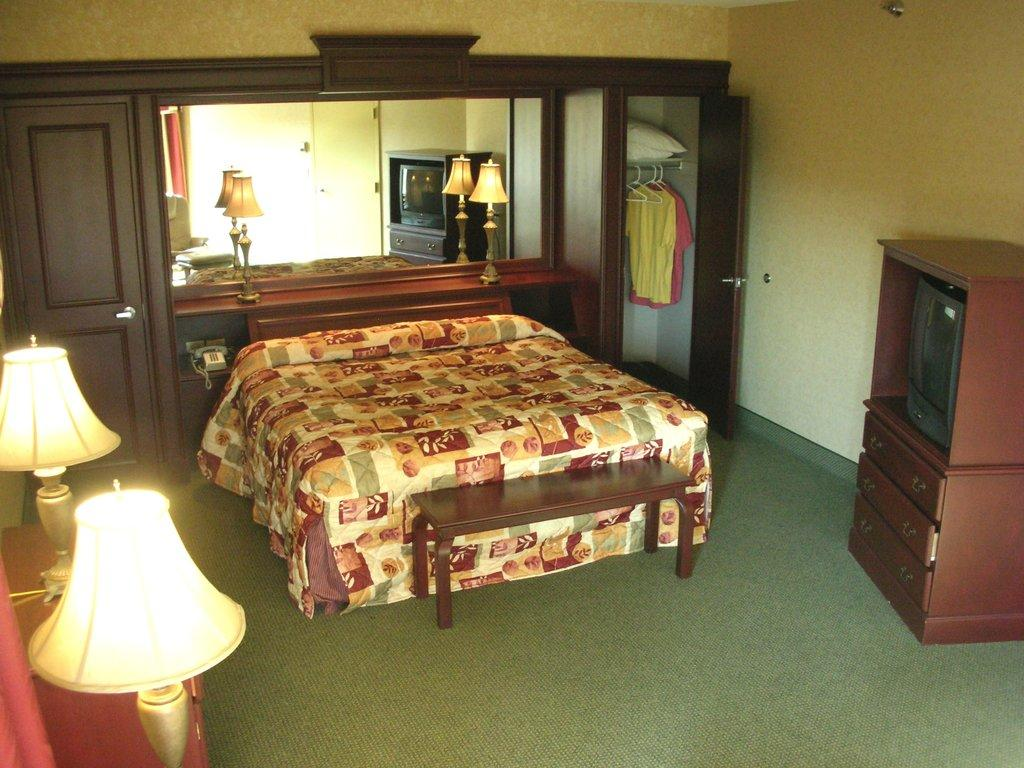Where was the image taken? The image was taken inside a house. What piece of furniture can be seen in the image? There is a bed in the image. What electronic device is present in the image? There is a television in the image. What type of storage furniture is in the image? There is a cupboard in the image. What type of lighting is present in the image? There are bed lamps in the image. What type of door is in the image? There is a wooden door in the image. What type of company does the dad own, as seen in the image? There is no reference to a company or dad in the image, so it is not possible to answer that question. 